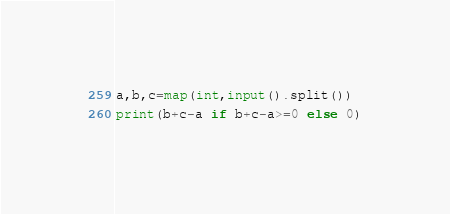Convert code to text. <code><loc_0><loc_0><loc_500><loc_500><_Python_>a,b,c=map(int,input().split())
print(b+c-a if b+c-a>=0 else 0)</code> 